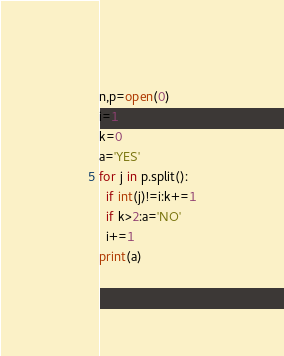<code> <loc_0><loc_0><loc_500><loc_500><_Python_>n,p=open(0)
i=1
k=0
a='YES'
for j in p.split():
  if int(j)!=i:k+=1
  if k>2:a='NO'
  i+=1
print(a)</code> 